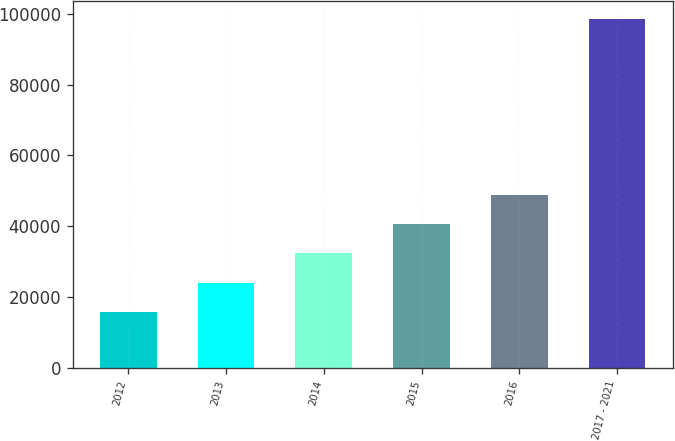Convert chart to OTSL. <chart><loc_0><loc_0><loc_500><loc_500><bar_chart><fcel>2012<fcel>2013<fcel>2014<fcel>2015<fcel>2016<fcel>2017 - 2021<nl><fcel>15836<fcel>24117.5<fcel>32399<fcel>40680.5<fcel>48962<fcel>98651<nl></chart> 